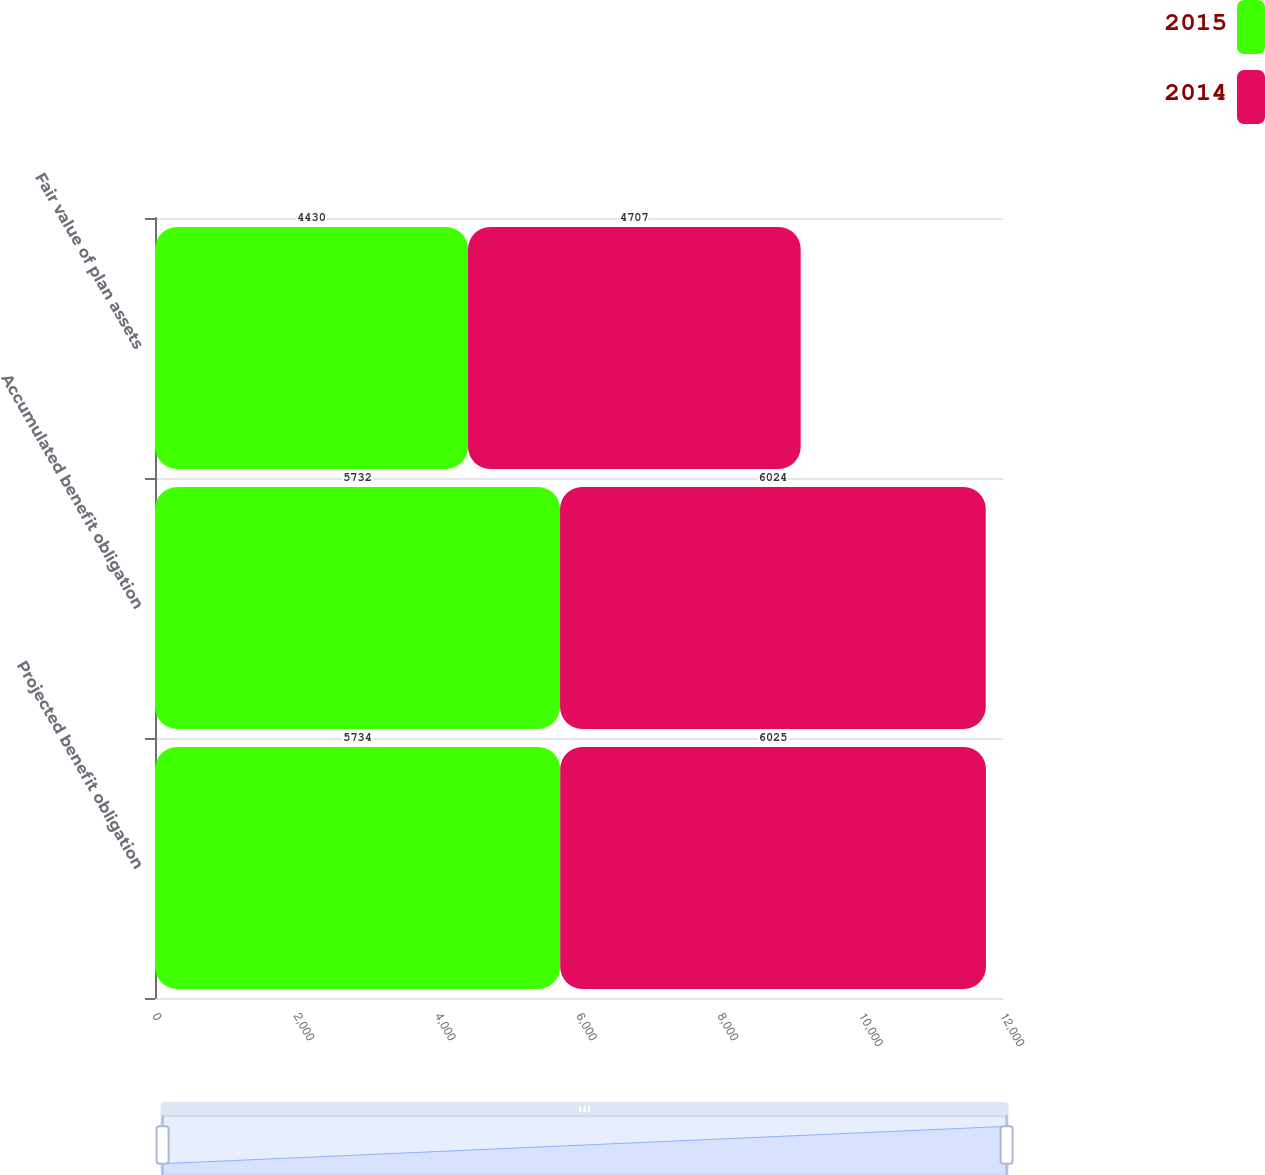Convert chart to OTSL. <chart><loc_0><loc_0><loc_500><loc_500><stacked_bar_chart><ecel><fcel>Projected benefit obligation<fcel>Accumulated benefit obligation<fcel>Fair value of plan assets<nl><fcel>2015<fcel>5734<fcel>5732<fcel>4430<nl><fcel>2014<fcel>6025<fcel>6024<fcel>4707<nl></chart> 